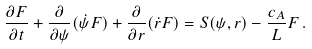<formula> <loc_0><loc_0><loc_500><loc_500>\frac { \partial F } { \partial t } + \frac { \partial } { \partial \psi } ( \dot { \psi } F ) + \frac { \partial } { \partial r } ( \dot { r } F ) = S ( \psi , r ) - \frac { c _ { A } } { L } F \, .</formula> 